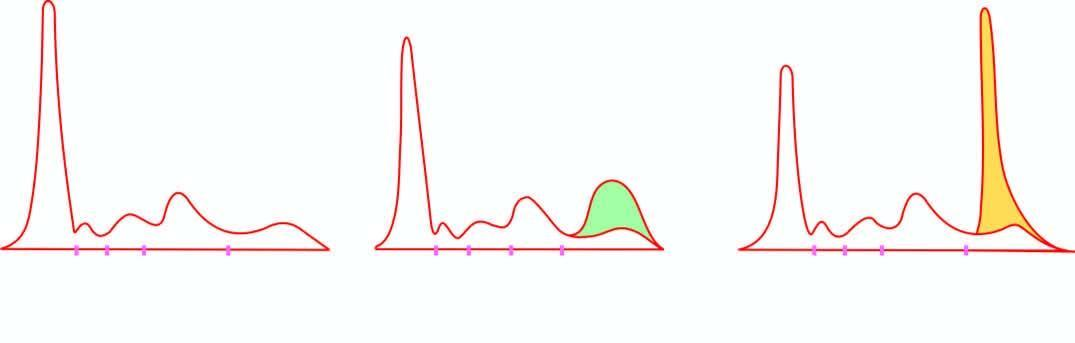what did serum electrophoresis show?
Answer the question using a single word or phrase. Normal serum pattern 